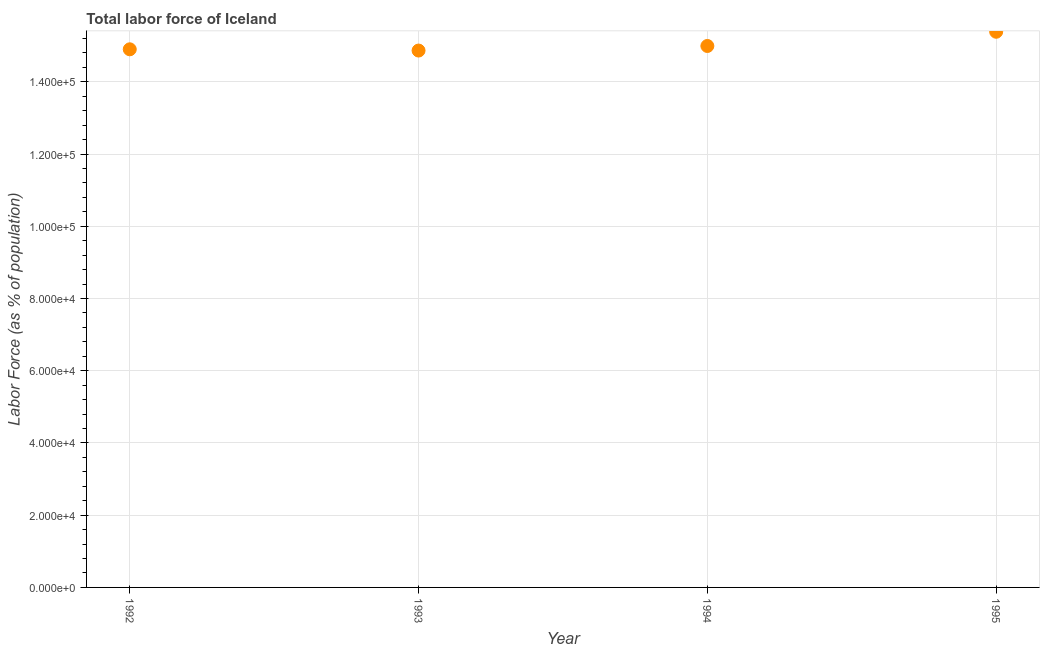What is the total labor force in 1992?
Offer a terse response. 1.49e+05. Across all years, what is the maximum total labor force?
Provide a succinct answer. 1.54e+05. Across all years, what is the minimum total labor force?
Give a very brief answer. 1.49e+05. In which year was the total labor force maximum?
Your answer should be very brief. 1995. In which year was the total labor force minimum?
Offer a very short reply. 1993. What is the sum of the total labor force?
Provide a succinct answer. 6.01e+05. What is the difference between the total labor force in 1993 and 1995?
Your answer should be compact. -5203. What is the average total labor force per year?
Ensure brevity in your answer.  1.50e+05. What is the median total labor force?
Keep it short and to the point. 1.49e+05. What is the ratio of the total labor force in 1992 to that in 1993?
Your answer should be very brief. 1. Is the total labor force in 1992 less than that in 1995?
Ensure brevity in your answer.  Yes. Is the difference between the total labor force in 1992 and 1993 greater than the difference between any two years?
Keep it short and to the point. No. What is the difference between the highest and the second highest total labor force?
Provide a short and direct response. 3936. Is the sum of the total labor force in 1993 and 1995 greater than the maximum total labor force across all years?
Offer a very short reply. Yes. What is the difference between the highest and the lowest total labor force?
Your answer should be compact. 5203. In how many years, is the total labor force greater than the average total labor force taken over all years?
Your answer should be very brief. 1. How many years are there in the graph?
Provide a short and direct response. 4. What is the difference between two consecutive major ticks on the Y-axis?
Provide a short and direct response. 2.00e+04. Are the values on the major ticks of Y-axis written in scientific E-notation?
Your response must be concise. Yes. What is the title of the graph?
Provide a succinct answer. Total labor force of Iceland. What is the label or title of the X-axis?
Provide a succinct answer. Year. What is the label or title of the Y-axis?
Provide a succinct answer. Labor Force (as % of population). What is the Labor Force (as % of population) in 1992?
Offer a terse response. 1.49e+05. What is the Labor Force (as % of population) in 1993?
Make the answer very short. 1.49e+05. What is the Labor Force (as % of population) in 1994?
Keep it short and to the point. 1.50e+05. What is the Labor Force (as % of population) in 1995?
Offer a terse response. 1.54e+05. What is the difference between the Labor Force (as % of population) in 1992 and 1993?
Give a very brief answer. 347. What is the difference between the Labor Force (as % of population) in 1992 and 1994?
Provide a succinct answer. -920. What is the difference between the Labor Force (as % of population) in 1992 and 1995?
Your answer should be compact. -4856. What is the difference between the Labor Force (as % of population) in 1993 and 1994?
Provide a short and direct response. -1267. What is the difference between the Labor Force (as % of population) in 1993 and 1995?
Your answer should be compact. -5203. What is the difference between the Labor Force (as % of population) in 1994 and 1995?
Your response must be concise. -3936. What is the ratio of the Labor Force (as % of population) in 1992 to that in 1993?
Offer a very short reply. 1. What is the ratio of the Labor Force (as % of population) in 1993 to that in 1994?
Your answer should be very brief. 0.99. What is the ratio of the Labor Force (as % of population) in 1993 to that in 1995?
Offer a terse response. 0.97. 